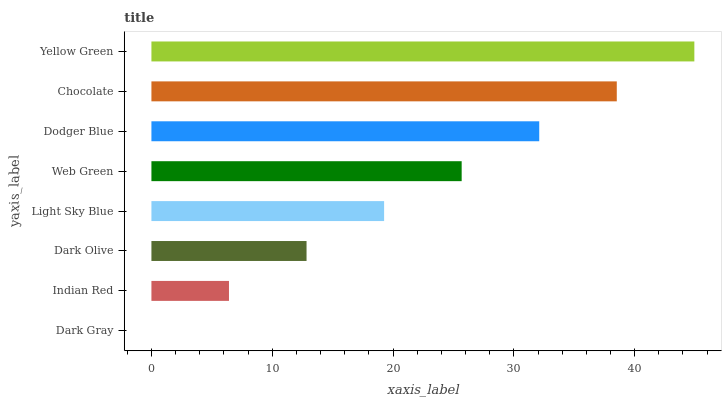Is Dark Gray the minimum?
Answer yes or no. Yes. Is Yellow Green the maximum?
Answer yes or no. Yes. Is Indian Red the minimum?
Answer yes or no. No. Is Indian Red the maximum?
Answer yes or no. No. Is Indian Red greater than Dark Gray?
Answer yes or no. Yes. Is Dark Gray less than Indian Red?
Answer yes or no. Yes. Is Dark Gray greater than Indian Red?
Answer yes or no. No. Is Indian Red less than Dark Gray?
Answer yes or no. No. Is Web Green the high median?
Answer yes or no. Yes. Is Light Sky Blue the low median?
Answer yes or no. Yes. Is Light Sky Blue the high median?
Answer yes or no. No. Is Dark Gray the low median?
Answer yes or no. No. 